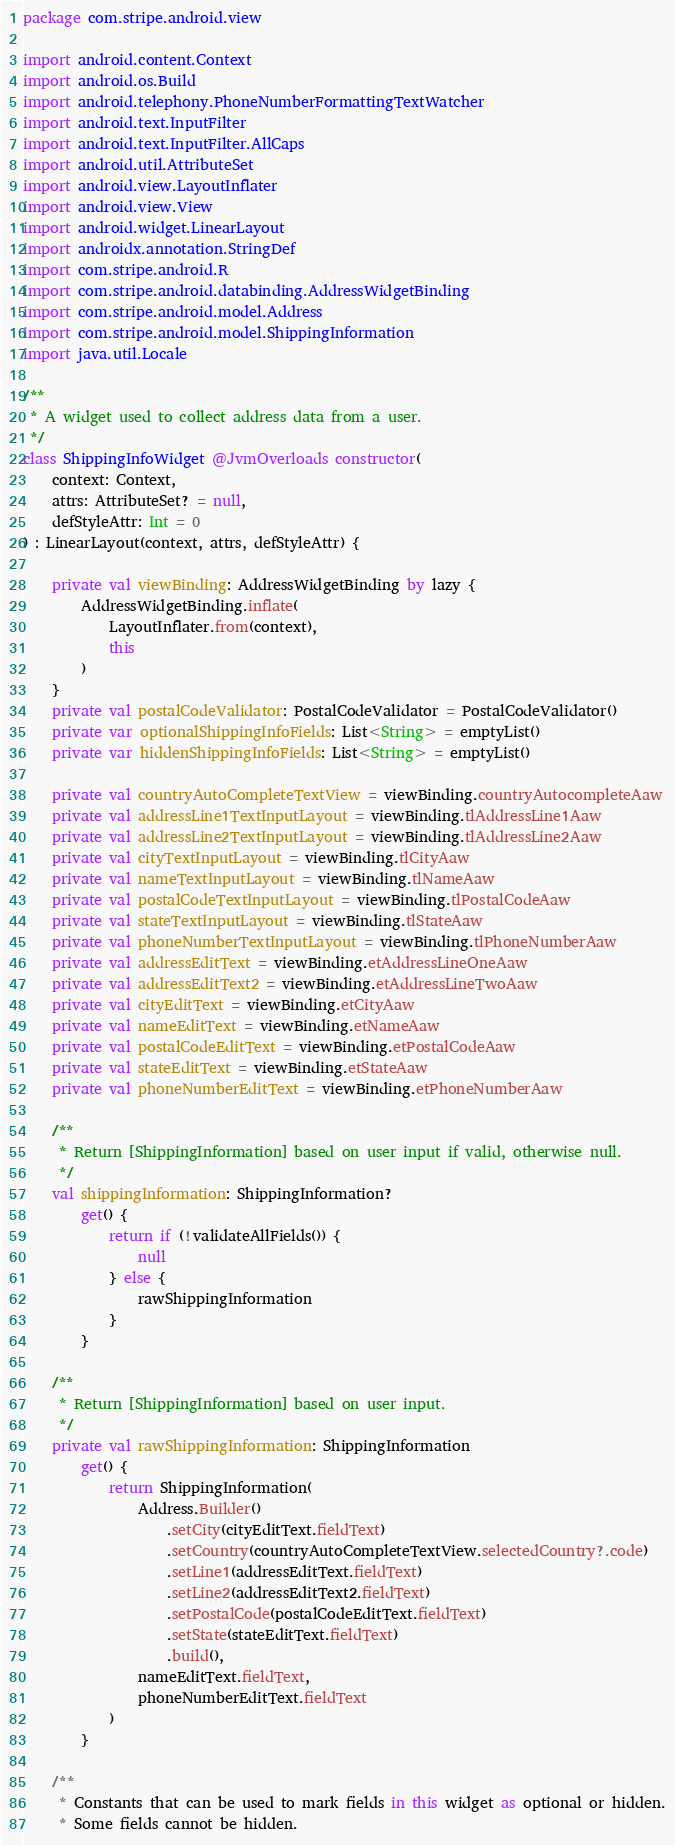Convert code to text. <code><loc_0><loc_0><loc_500><loc_500><_Kotlin_>package com.stripe.android.view

import android.content.Context
import android.os.Build
import android.telephony.PhoneNumberFormattingTextWatcher
import android.text.InputFilter
import android.text.InputFilter.AllCaps
import android.util.AttributeSet
import android.view.LayoutInflater
import android.view.View
import android.widget.LinearLayout
import androidx.annotation.StringDef
import com.stripe.android.R
import com.stripe.android.databinding.AddressWidgetBinding
import com.stripe.android.model.Address
import com.stripe.android.model.ShippingInformation
import java.util.Locale

/**
 * A widget used to collect address data from a user.
 */
class ShippingInfoWidget @JvmOverloads constructor(
    context: Context,
    attrs: AttributeSet? = null,
    defStyleAttr: Int = 0
) : LinearLayout(context, attrs, defStyleAttr) {

    private val viewBinding: AddressWidgetBinding by lazy {
        AddressWidgetBinding.inflate(
            LayoutInflater.from(context),
            this
        )
    }
    private val postalCodeValidator: PostalCodeValidator = PostalCodeValidator()
    private var optionalShippingInfoFields: List<String> = emptyList()
    private var hiddenShippingInfoFields: List<String> = emptyList()

    private val countryAutoCompleteTextView = viewBinding.countryAutocompleteAaw
    private val addressLine1TextInputLayout = viewBinding.tlAddressLine1Aaw
    private val addressLine2TextInputLayout = viewBinding.tlAddressLine2Aaw
    private val cityTextInputLayout = viewBinding.tlCityAaw
    private val nameTextInputLayout = viewBinding.tlNameAaw
    private val postalCodeTextInputLayout = viewBinding.tlPostalCodeAaw
    private val stateTextInputLayout = viewBinding.tlStateAaw
    private val phoneNumberTextInputLayout = viewBinding.tlPhoneNumberAaw
    private val addressEditText = viewBinding.etAddressLineOneAaw
    private val addressEditText2 = viewBinding.etAddressLineTwoAaw
    private val cityEditText = viewBinding.etCityAaw
    private val nameEditText = viewBinding.etNameAaw
    private val postalCodeEditText = viewBinding.etPostalCodeAaw
    private val stateEditText = viewBinding.etStateAaw
    private val phoneNumberEditText = viewBinding.etPhoneNumberAaw

    /**
     * Return [ShippingInformation] based on user input if valid, otherwise null.
     */
    val shippingInformation: ShippingInformation?
        get() {
            return if (!validateAllFields()) {
                null
            } else {
                rawShippingInformation
            }
        }

    /**
     * Return [ShippingInformation] based on user input.
     */
    private val rawShippingInformation: ShippingInformation
        get() {
            return ShippingInformation(
                Address.Builder()
                    .setCity(cityEditText.fieldText)
                    .setCountry(countryAutoCompleteTextView.selectedCountry?.code)
                    .setLine1(addressEditText.fieldText)
                    .setLine2(addressEditText2.fieldText)
                    .setPostalCode(postalCodeEditText.fieldText)
                    .setState(stateEditText.fieldText)
                    .build(),
                nameEditText.fieldText,
                phoneNumberEditText.fieldText
            )
        }

    /**
     * Constants that can be used to mark fields in this widget as optional or hidden.
     * Some fields cannot be hidden.</code> 